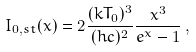Convert formula to latex. <formula><loc_0><loc_0><loc_500><loc_500>I _ { 0 , s t } ( x ) = 2 \frac { ( k T _ { 0 } ) ^ { 3 } } { ( h c ) ^ { 2 } } \frac { x ^ { 3 } } { e ^ { x } - 1 } \, ,</formula> 